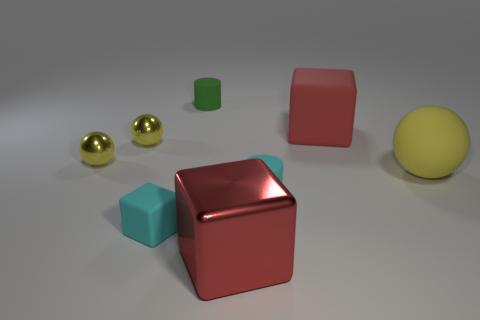Does the matte cylinder that is behind the yellow matte sphere have the same size as the large rubber ball?
Your answer should be compact. No. Does the cyan cube have the same material as the tiny cyan object that is on the right side of the small green matte object?
Your answer should be compact. Yes. What is the color of the large block that is in front of the large red rubber cube?
Your answer should be compact. Red. Are there any small rubber cylinders that are right of the tiny green cylinder on the left side of the large red rubber block?
Make the answer very short. Yes. There is a big thing behind the large sphere; is it the same color as the large block that is on the left side of the cyan matte cylinder?
Offer a terse response. Yes. There is a large yellow ball; what number of tiny yellow metal objects are in front of it?
Ensure brevity in your answer.  0. How many shiny objects are the same color as the big rubber ball?
Give a very brief answer. 2. Does the red object that is in front of the small cyan cylinder have the same material as the tiny green object?
Provide a succinct answer. No. How many tiny objects are the same material as the large yellow sphere?
Your answer should be very brief. 3. Are there more objects that are to the left of the tiny green cylinder than big matte objects?
Your answer should be compact. Yes. 